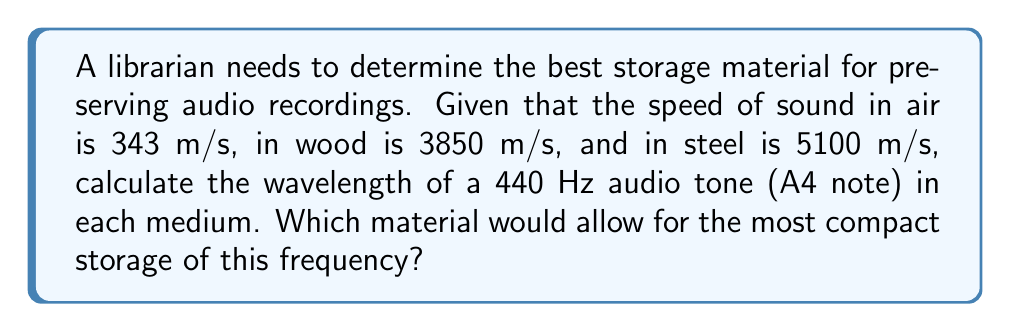Show me your answer to this math problem. To solve this problem, we'll use the wave equation:

$$ v = f\lambda $$

Where:
$v$ = speed of sound in the medium
$f$ = frequency of the sound wave
$\lambda$ = wavelength

We'll calculate the wavelength for each medium:

1. Air:
   $$ 343 = 440 \lambda_{air} $$
   $$ \lambda_{air} = \frac{343}{440} \approx 0.78 \text{ m} $$

2. Wood:
   $$ 3850 = 440 \lambda_{wood} $$
   $$ \lambda_{wood} = \frac{3850}{440} \approx 8.75 \text{ m} $$

3. Steel:
   $$ 5100 = 440 \lambda_{steel} $$
   $$ \lambda_{steel} = \frac{5100}{440} \approx 11.59 \text{ m} $$

The material with the shortest wavelength would allow for the most compact storage, as it requires less physical space to represent one complete cycle of the sound wave. In this case, air has the shortest wavelength at approximately 0.78 m.
Answer: Air (wavelength ≈ 0.78 m) 